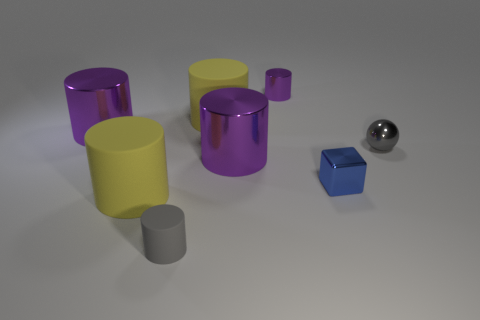Is there any other thing that is the same shape as the gray matte thing?
Keep it short and to the point. Yes. Do the yellow rubber cylinder behind the block and the purple shiny cylinder that is in front of the gray ball have the same size?
Your answer should be compact. Yes. How many things are small cylinders or gray things that are to the left of the gray ball?
Offer a terse response. 2. There is a purple metallic object that is in front of the tiny gray metal sphere; what is its size?
Provide a succinct answer. Large. Are there fewer tiny rubber cylinders on the right side of the small gray metal thing than small gray rubber objects right of the tiny blue cube?
Your answer should be compact. No. What is the material of the small object that is both in front of the tiny purple thing and to the left of the tiny blue object?
Provide a short and direct response. Rubber. What shape is the large shiny thing behind the tiny metal object that is on the right side of the metallic block?
Offer a very short reply. Cylinder. Does the ball have the same color as the small block?
Your response must be concise. No. How many cyan objects are tiny metallic spheres or metal objects?
Your response must be concise. 0. Are there any small metallic cylinders behind the small purple thing?
Keep it short and to the point. No. 